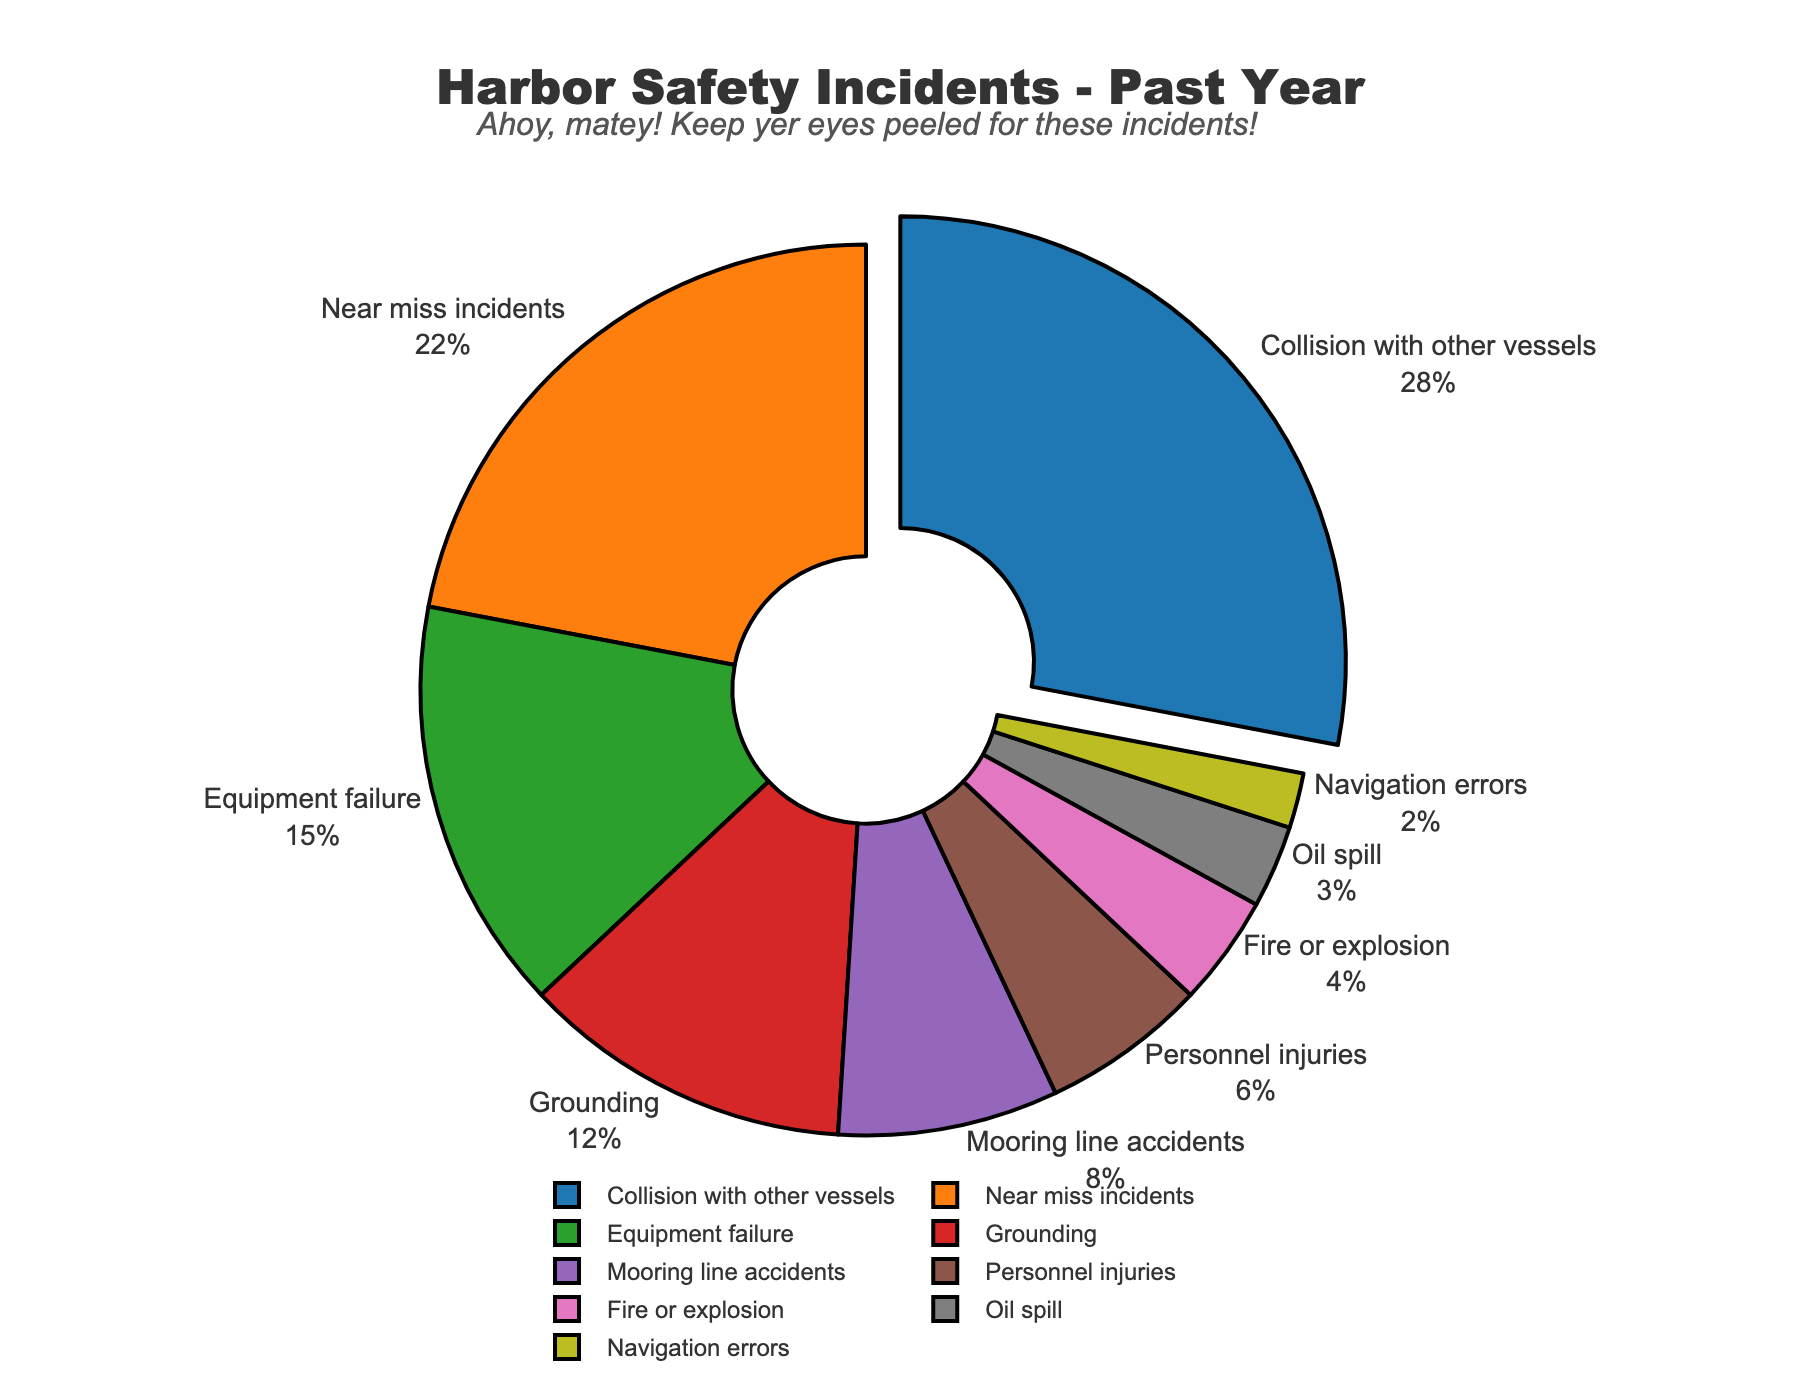Which type of incident has the highest proportion? The slice of the pie chart that represents "Collision with other vessels" is pulled out, indicating it has the highest proportion.
Answer: Collision with other vessels Which two types of incidents together make up 50% of the reported incidents? "Collision with other vessels" and "Near miss incidents" are 28% and 22% respectively. Adding these two gives us 50%.
Answer: Collision with other vessels and Near miss incidents What is the difference in percentage between the incidents "Mooring line accidents" and "Oil spill"? "Mooring line accidents" is at 8% and "Oil spill" is at 3%. Subtracting Oil spill from Mooring line accidents gives 8% - 3% = 5%.
Answer: 5% Which type of incident has the lowest proportion? By looking at the smallest slice in the pie chart, we can see that "Navigation errors" is the smallest at 2%.
Answer: Navigation errors What is the total percentage of incidents related to human error (collision, near miss, and navigation errors)? Adding percentages for "Collision with other vessels" (28%), "Near miss incidents" (22%), and "Navigation errors" (2%) gives us 28% + 22% + 2% = 52%.
Answer: 52% Is the proportion of personnel injuries higher or lower than equipment failure? "Personnel injuries" has a proportion of 6% while "Equipment failure" has a proportion of 15%. Comparing these two, 6% is lower than 15%.
Answer: Lower On average, what is the percentage of incidents for "Grounding", "Mooring line accidents", and "Personnel injuries"? Adding percentages for "Grounding" (12%), "Mooring line accidents" (8%), and "Personnel injuries" (6%) gives us 12% + 8% + 6% = 26%. Dividing by 3, the average is 26% / 3 ≈ 8.67%.
Answer: 8.67% Which incident type has a proportion that is double that of oil spills? Oil spill is 3%. The incident type with 6%, which is double 3%, is "Personnel injuries".
Answer: Personnel injuries What is the combined proportion for incidents related to equipment (equipment failure, fire or explosion, and oil spills)? Adding percentages for "Equipment failure" (15%), "Fire or explosion" (4%), and "Oil spill" (3%) gives us 15% + 4% + 3% = 22%.
Answer: 22% Which individual incident has the closest proportion to the sum of "Grounding" and "Navigation errors"? "Grounding" is 12% and "Navigation errors" is 2%. The sum is 12% + 2% = 14%. The closest individual proportion is "Equipment failure" at 15%, which is 1% more.
Answer: Equipment failure 